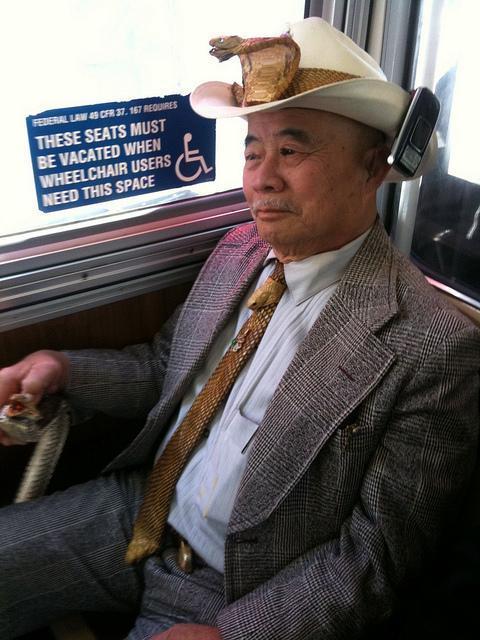How many dogs are relaxing?
Give a very brief answer. 0. 